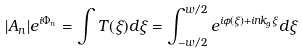Convert formula to latex. <formula><loc_0><loc_0><loc_500><loc_500>| A _ { n } | e ^ { i \Phi _ { n } } = \int T ( \xi ) d \xi = \int _ { - w / 2 } ^ { w / 2 } e ^ { i \phi ( \xi ) + i n k _ { g } \xi } d \xi</formula> 